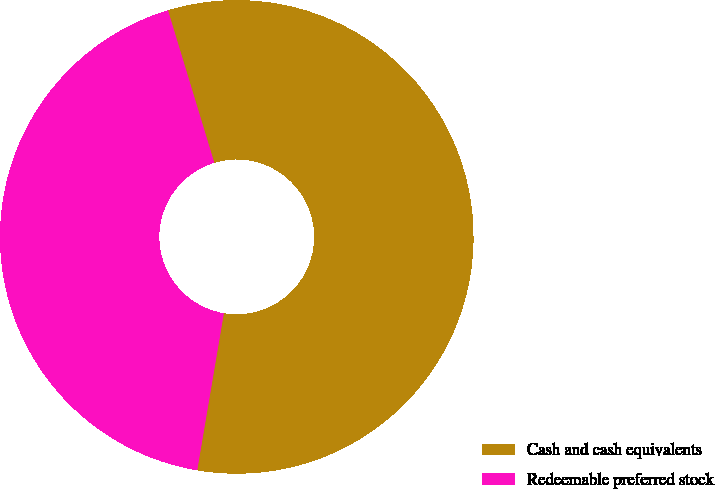<chart> <loc_0><loc_0><loc_500><loc_500><pie_chart><fcel>Cash and cash equivalents<fcel>Redeemable preferred stock<nl><fcel>57.37%<fcel>42.63%<nl></chart> 